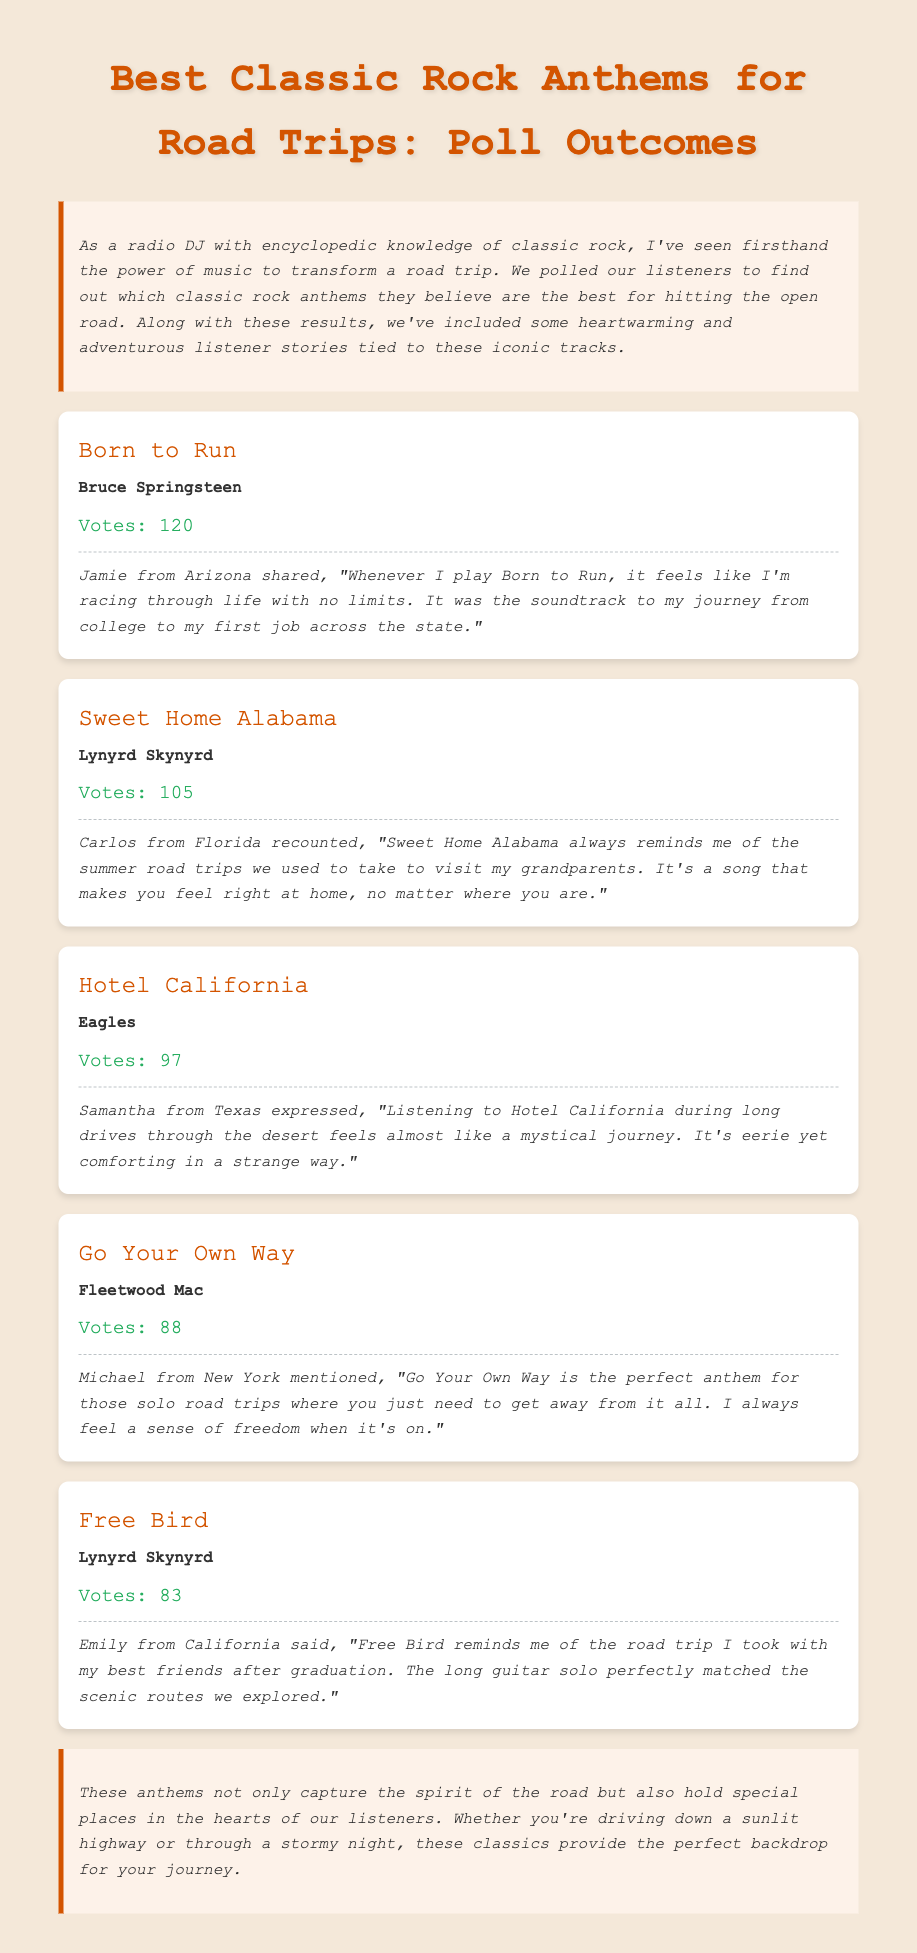What is the title of the document? The title of the document is included in the header section as "Best Classic Rock Anthems for Road Trips: Poll Outcomes."
Answer: Best Classic Rock Anthems for Road Trips: Poll Outcomes How many votes did "Born to Run" receive? The votes for "Born to Run" are explicitly stated in the document as 120.
Answer: 120 Which song received the second-highest number of votes? By comparing the vote counts listed, "Sweet Home Alabama" received 105 votes, making it the second-highest.
Answer: Sweet Home Alabama Who shared a story about "Free Bird"? The document includes a story from Emily, who is from California, related to "Free Bird."
Answer: Emily What does Jamie from Arizona associate with "Born to Run"? Jamie connects "Born to Run" with their journey from college to their first job across the state.
Answer: Journey from college to first job Which song is described as "eerie yet comforting"? The song described in this way is "Hotel California" according to Samantha from Texas.
Answer: Hotel California How many votes did "Go Your Own Way" receive? The document states that "Go Your Own Way" received a total of 88 votes.
Answer: 88 What theme do all the stories share? The stories all revolve around personal experiences linked to specific songs during road trips.
Answer: Personal experiences during road trips 